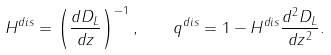<formula> <loc_0><loc_0><loc_500><loc_500>H ^ { d i s } = \left ( \frac { d D _ { L } } { d z } \right ) ^ { - 1 } , \quad q ^ { d i s } = 1 - H ^ { d i s } \frac { d ^ { 2 } D _ { L } } { d z ^ { 2 } } .</formula> 